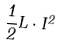<formula> <loc_0><loc_0><loc_500><loc_500>\frac { 1 } { 2 } L \cdot I ^ { 2 }</formula> 